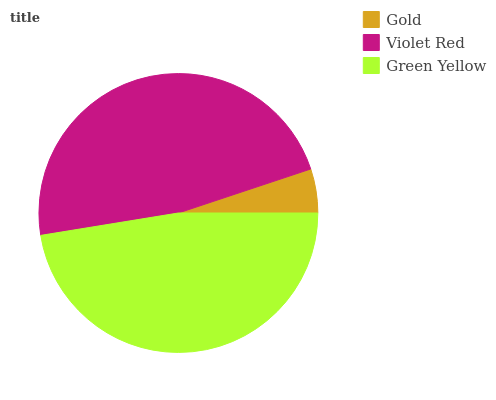Is Gold the minimum?
Answer yes or no. Yes. Is Violet Red the maximum?
Answer yes or no. Yes. Is Green Yellow the minimum?
Answer yes or no. No. Is Green Yellow the maximum?
Answer yes or no. No. Is Violet Red greater than Green Yellow?
Answer yes or no. Yes. Is Green Yellow less than Violet Red?
Answer yes or no. Yes. Is Green Yellow greater than Violet Red?
Answer yes or no. No. Is Violet Red less than Green Yellow?
Answer yes or no. No. Is Green Yellow the high median?
Answer yes or no. Yes. Is Green Yellow the low median?
Answer yes or no. Yes. Is Violet Red the high median?
Answer yes or no. No. Is Gold the low median?
Answer yes or no. No. 